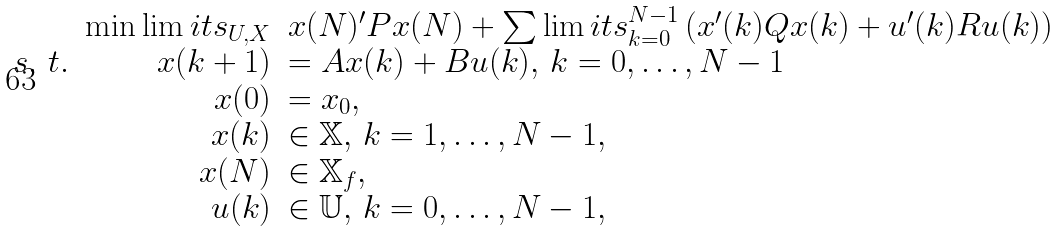<formula> <loc_0><loc_0><loc_500><loc_500>\begin{array} { r r l } & \min \lim i t s _ { U , X } & x ( N ) ^ { \prime } P x ( N ) + \sum \lim i t s _ { k = 0 } ^ { N - 1 } \left ( x ^ { \prime } ( k ) Q x ( k ) + u ^ { \prime } ( k ) R u ( k ) \right ) \\ s . \ t . & x ( k + 1 ) & = A x ( k ) + B u ( k ) , \, k = 0 , \dots , N - 1 \\ & x ( 0 ) & = x _ { 0 } , \\ & x ( k ) & \in \mathbb { X } , \, k = 1 , \dots , N - 1 , \\ & x ( N ) & \in \mathbb { X } _ { f } , \\ & u ( k ) & \in \mathbb { U } , \, k = 0 , \dots , N - 1 , \end{array}</formula> 